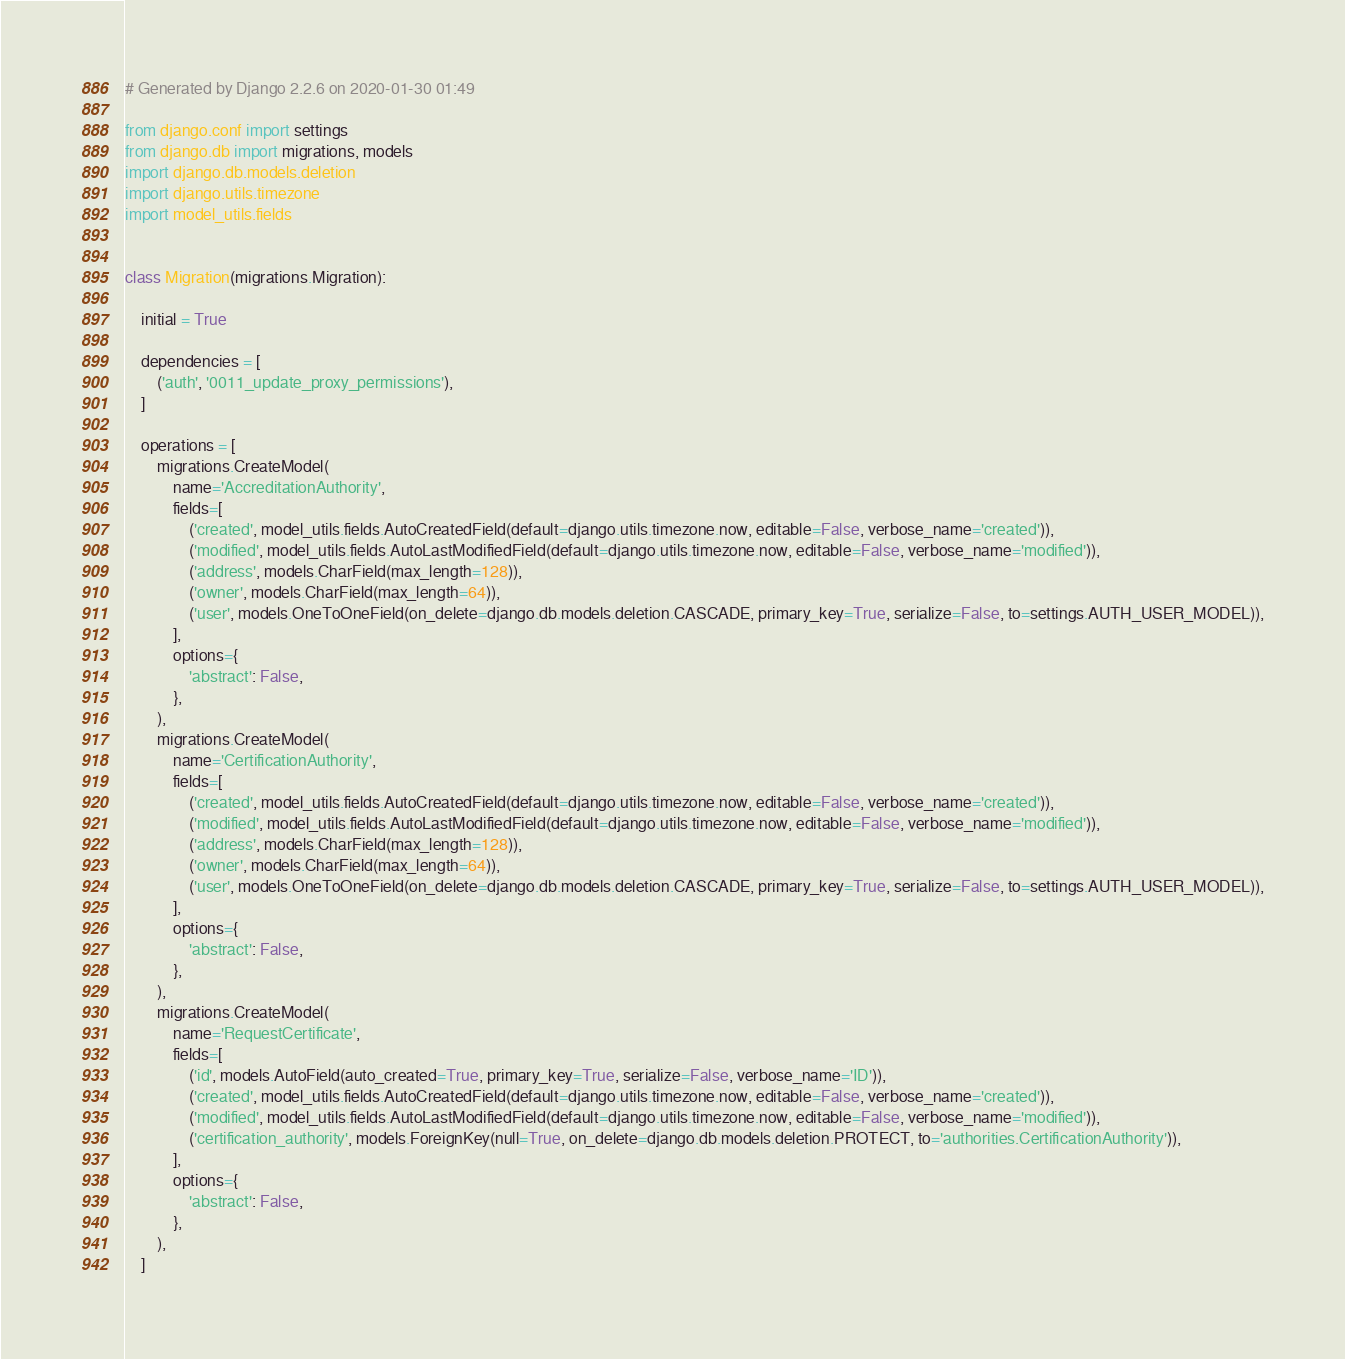<code> <loc_0><loc_0><loc_500><loc_500><_Python_># Generated by Django 2.2.6 on 2020-01-30 01:49

from django.conf import settings
from django.db import migrations, models
import django.db.models.deletion
import django.utils.timezone
import model_utils.fields


class Migration(migrations.Migration):

    initial = True

    dependencies = [
        ('auth', '0011_update_proxy_permissions'),
    ]

    operations = [
        migrations.CreateModel(
            name='AccreditationAuthority',
            fields=[
                ('created', model_utils.fields.AutoCreatedField(default=django.utils.timezone.now, editable=False, verbose_name='created')),
                ('modified', model_utils.fields.AutoLastModifiedField(default=django.utils.timezone.now, editable=False, verbose_name='modified')),
                ('address', models.CharField(max_length=128)),
                ('owner', models.CharField(max_length=64)),
                ('user', models.OneToOneField(on_delete=django.db.models.deletion.CASCADE, primary_key=True, serialize=False, to=settings.AUTH_USER_MODEL)),
            ],
            options={
                'abstract': False,
            },
        ),
        migrations.CreateModel(
            name='CertificationAuthority',
            fields=[
                ('created', model_utils.fields.AutoCreatedField(default=django.utils.timezone.now, editable=False, verbose_name='created')),
                ('modified', model_utils.fields.AutoLastModifiedField(default=django.utils.timezone.now, editable=False, verbose_name='modified')),
                ('address', models.CharField(max_length=128)),
                ('owner', models.CharField(max_length=64)),
                ('user', models.OneToOneField(on_delete=django.db.models.deletion.CASCADE, primary_key=True, serialize=False, to=settings.AUTH_USER_MODEL)),
            ],
            options={
                'abstract': False,
            },
        ),
        migrations.CreateModel(
            name='RequestCertificate',
            fields=[
                ('id', models.AutoField(auto_created=True, primary_key=True, serialize=False, verbose_name='ID')),
                ('created', model_utils.fields.AutoCreatedField(default=django.utils.timezone.now, editable=False, verbose_name='created')),
                ('modified', model_utils.fields.AutoLastModifiedField(default=django.utils.timezone.now, editable=False, verbose_name='modified')),
                ('certification_authority', models.ForeignKey(null=True, on_delete=django.db.models.deletion.PROTECT, to='authorities.CertificationAuthority')),
            ],
            options={
                'abstract': False,
            },
        ),
    ]
</code> 